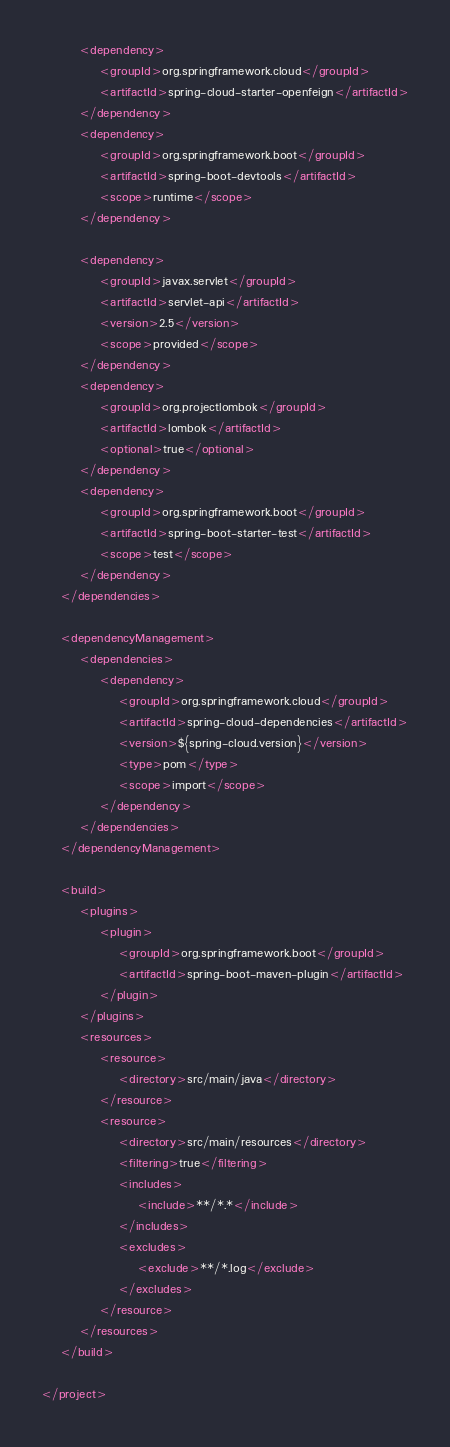<code> <loc_0><loc_0><loc_500><loc_500><_XML_>
		<dependency>
			<groupId>org.springframework.cloud</groupId>
			<artifactId>spring-cloud-starter-openfeign</artifactId>
		</dependency>
		<dependency>
			<groupId>org.springframework.boot</groupId>
			<artifactId>spring-boot-devtools</artifactId>
			<scope>runtime</scope>
		</dependency>

		<dependency>
			<groupId>javax.servlet</groupId>
			<artifactId>servlet-api</artifactId>
			<version>2.5</version>
			<scope>provided</scope>
		</dependency>
		<dependency>
			<groupId>org.projectlombok</groupId>
			<artifactId>lombok</artifactId>
			<optional>true</optional>
		</dependency>
		<dependency>
			<groupId>org.springframework.boot</groupId>
			<artifactId>spring-boot-starter-test</artifactId>
			<scope>test</scope>
		</dependency>
	</dependencies>

	<dependencyManagement>
		<dependencies>
			<dependency>
				<groupId>org.springframework.cloud</groupId>
				<artifactId>spring-cloud-dependencies</artifactId>
				<version>${spring-cloud.version}</version>
				<type>pom</type>
				<scope>import</scope>
			</dependency>
		</dependencies>
	</dependencyManagement>

	<build>
		<plugins>
			<plugin>
				<groupId>org.springframework.boot</groupId>
				<artifactId>spring-boot-maven-plugin</artifactId>
			</plugin>
		</plugins>
		<resources>
			<resource>
				<directory>src/main/java</directory>
			</resource>
			<resource>
				<directory>src/main/resources</directory>
				<filtering>true</filtering>
				<includes>
					<include>**/*.*</include>
				</includes>
				<excludes>
					<exclude>**/*.log</exclude>
				</excludes>
			</resource>
		</resources>
	</build>

</project></code> 